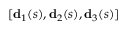<formula> <loc_0><loc_0><loc_500><loc_500>[ d _ { 1 } ( s ) , d _ { 2 } ( s ) , d _ { 3 } ( s ) ]</formula> 